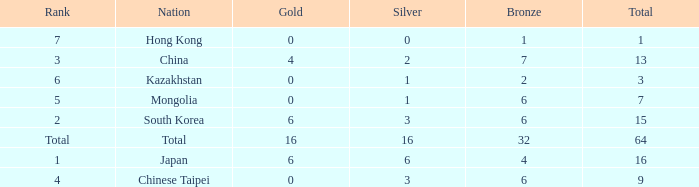Which Bronze is the lowest one that has a Rank of 3, and a Silver smaller than 2? None. Parse the table in full. {'header': ['Rank', 'Nation', 'Gold', 'Silver', 'Bronze', 'Total'], 'rows': [['7', 'Hong Kong', '0', '0', '1', '1'], ['3', 'China', '4', '2', '7', '13'], ['6', 'Kazakhstan', '0', '1', '2', '3'], ['5', 'Mongolia', '0', '1', '6', '7'], ['2', 'South Korea', '6', '3', '6', '15'], ['Total', 'Total', '16', '16', '32', '64'], ['1', 'Japan', '6', '6', '4', '16'], ['4', 'Chinese Taipei', '0', '3', '6', '9']]} 